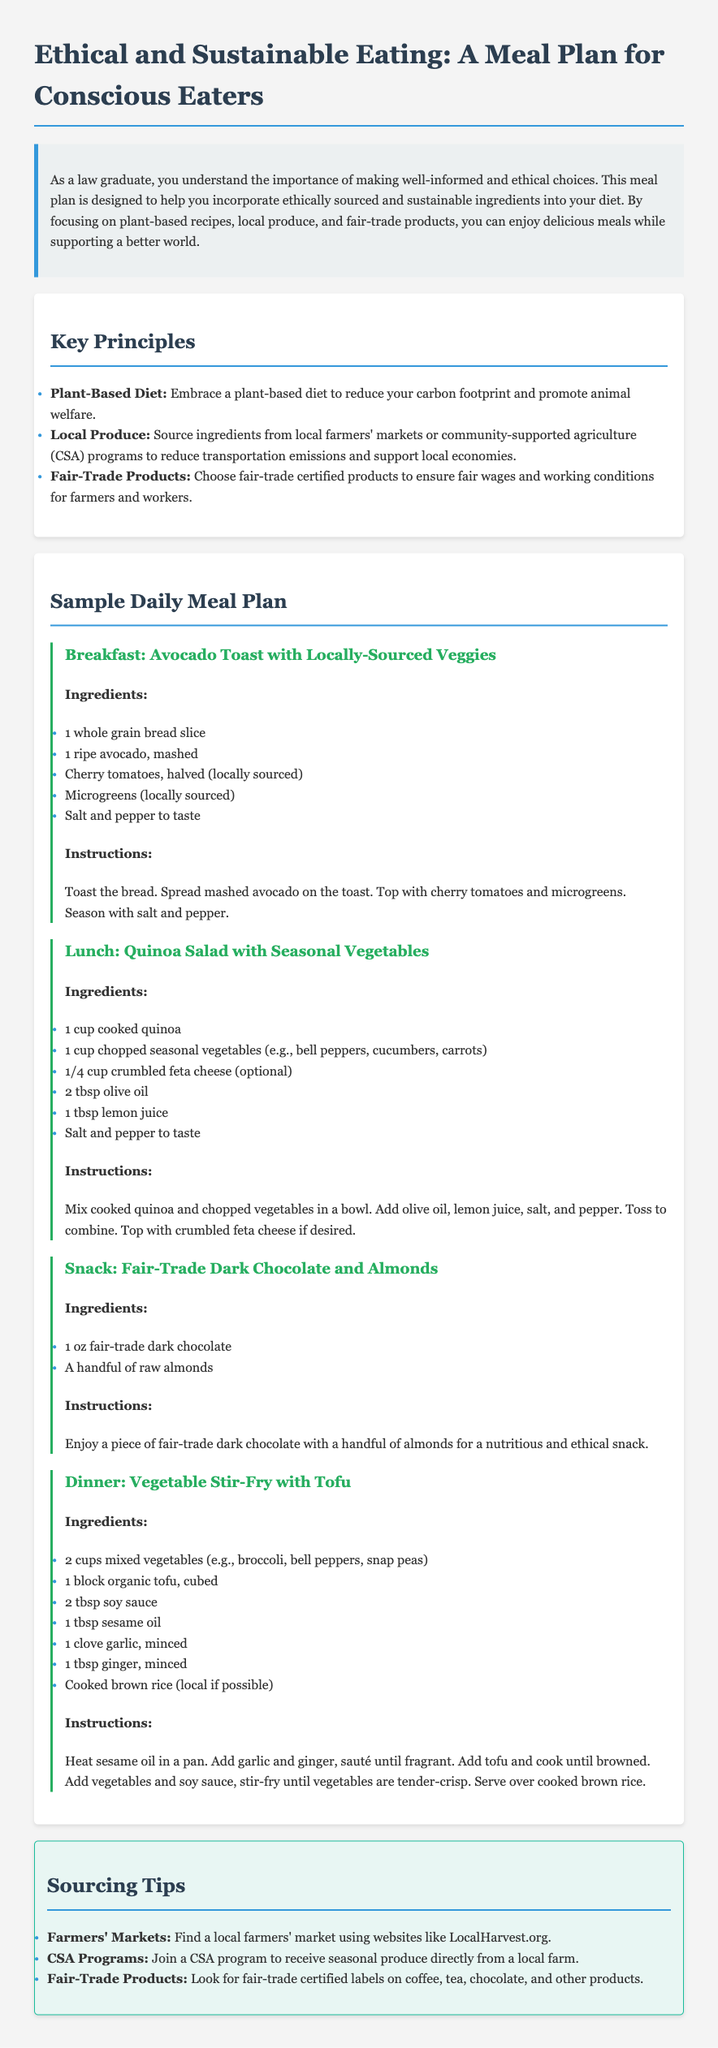what is the title of the document? The title is found at the top of the document, which states it clearly.
Answer: Ethical and Sustainable Eating: A Meal Plan for Conscious Eaters what is emphasized in this meal plan? The document outlines what the meal plan focuses on in its introduction.
Answer: Ethically sourced and sustainable ingredients which meal is recommended for breakfast? The document lists meals in a specific order, with breakfast mentioned first.
Answer: Avocado Toast with Locally-Sourced Veggies how many cups of mixed vegetables are used in the dinner recipe? The amount of mixed vegetables is specified in the dinner section of the meal plan.
Answer: 2 cups which type of diet is promoted in the meal plan? The key principles highlight the type of diet encouraged by the meal plan.
Answer: Plant-Based Diet name one sourcing tip provided in the document. The document offers specific suggestions for sourcing ingredients.
Answer: Join a CSA program what is the optional ingredient in the lunch recipe? The lunch recipe specifies an optional ingredient that can be included.
Answer: Feta cheese how is the snack described in the meal plan? The snack section describes the nature of the snack in a concise manner.
Answer: Nutritious and ethical snack what is one ingredient used in the stir-fry dinner? The dinner recipe lists several ingredients, and one of them can be singled out.
Answer: Tofu 